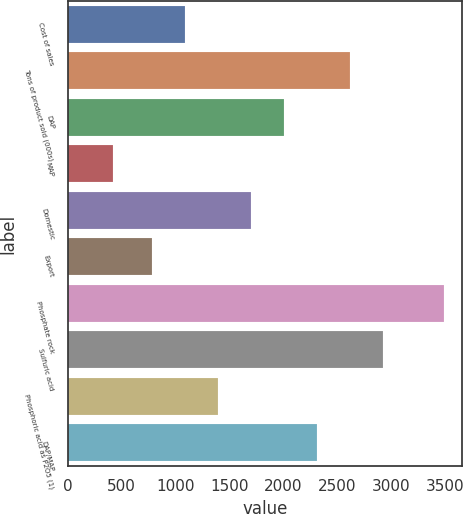Convert chart. <chart><loc_0><loc_0><loc_500><loc_500><bar_chart><fcel>Cost of sales<fcel>Tons of product sold (000s)<fcel>DAP<fcel>MAP<fcel>Domestic<fcel>Export<fcel>Phosphate rock<fcel>Sulfuric acid<fcel>Phosphoric acid as P2O5 (1)<fcel>DAP/MAP<nl><fcel>1086.9<fcel>2616.4<fcel>2004.6<fcel>424<fcel>1698.7<fcel>781<fcel>3483<fcel>2922.3<fcel>1392.8<fcel>2310.5<nl></chart> 